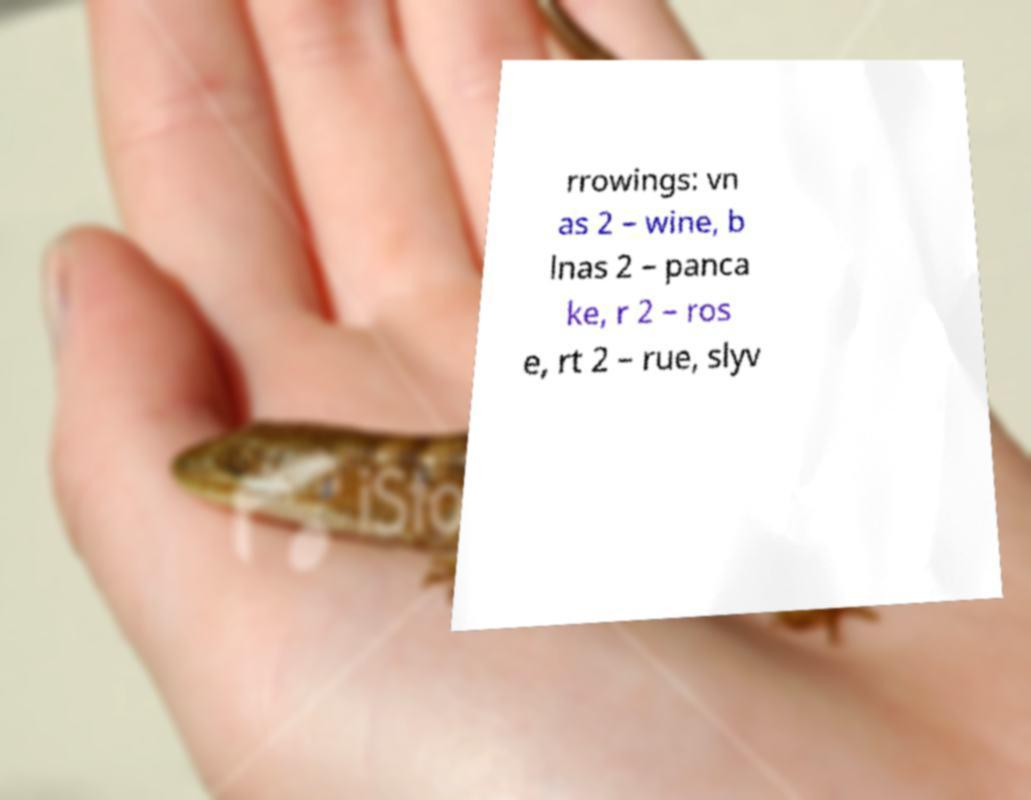Please identify and transcribe the text found in this image. rrowings: vn as 2 – wine, b lnas 2 – panca ke, r 2 – ros e, rt 2 – rue, slyv 